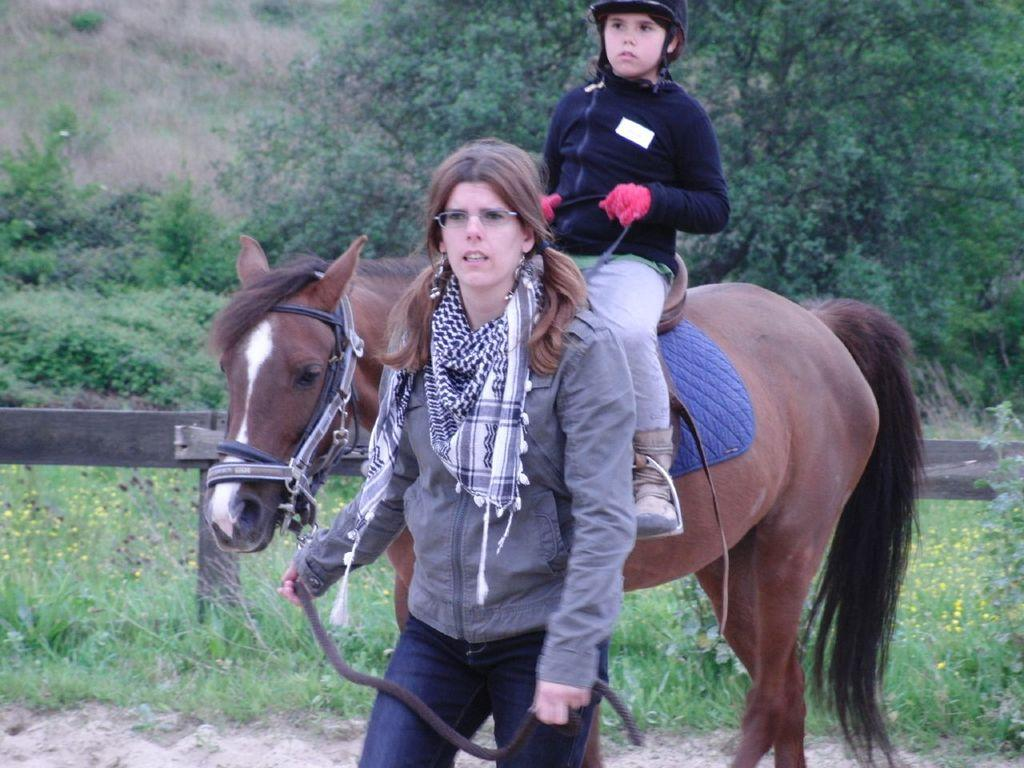What is the person in the image doing? The person is sitting on a horse in the image. Can you describe the woman in the image? There is a woman in the image, but her actions or appearance are not specified. What is the setting of the image? There is a fence and grass visible in the image, suggesting an outdoor setting. Trees are also visible in the background. What type of poison is being used to clean the stove in the image? There is no stove or poison present in the image. How does the drain affect the woman's actions in the image? There is no drain visible in the image, and the woman's actions are not specified. 